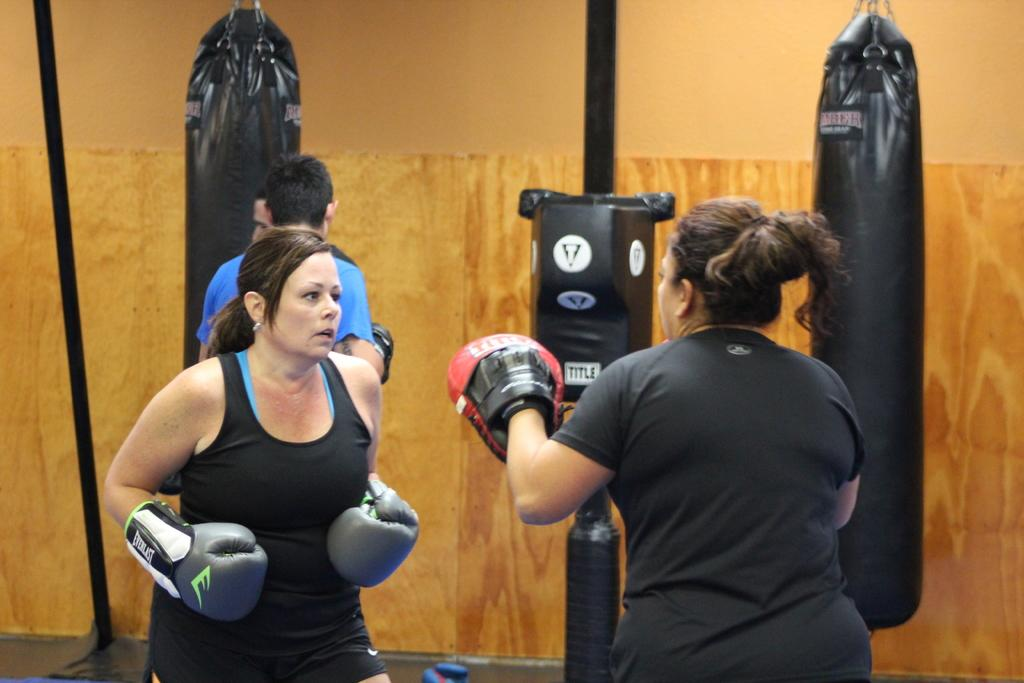What can be seen in the background of the image? There is a wall in the background of the image. Who is present in the image? There are people in the image. What type of equipment is visible in the image? Boxing bags are present in the image. What structures can be seen in the image? Poles are visible in the image. What objects are present in the image? There are objects in the image. What are the women in the image wearing? There are women wearing boxing gloves in the image. How many snails can be seen crawling on the boxing bags in the image? There are no snails present in the image; it features people, boxing bags, and poles. What color is the silver object in the image? There is no silver object present in the image. 